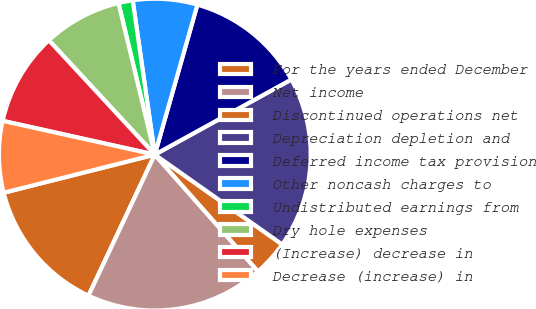<chart> <loc_0><loc_0><loc_500><loc_500><pie_chart><fcel>For the years ended December<fcel>Net income<fcel>Discontinued operations net<fcel>Depreciation depletion and<fcel>Deferred income tax provision<fcel>Other noncash charges to<fcel>Undistributed earnings from<fcel>Dry hole expenses<fcel>(Increase) decrease in<fcel>Decrease (increase) in<nl><fcel>14.07%<fcel>18.52%<fcel>3.7%<fcel>17.78%<fcel>12.59%<fcel>6.67%<fcel>1.48%<fcel>8.15%<fcel>9.63%<fcel>7.41%<nl></chart> 